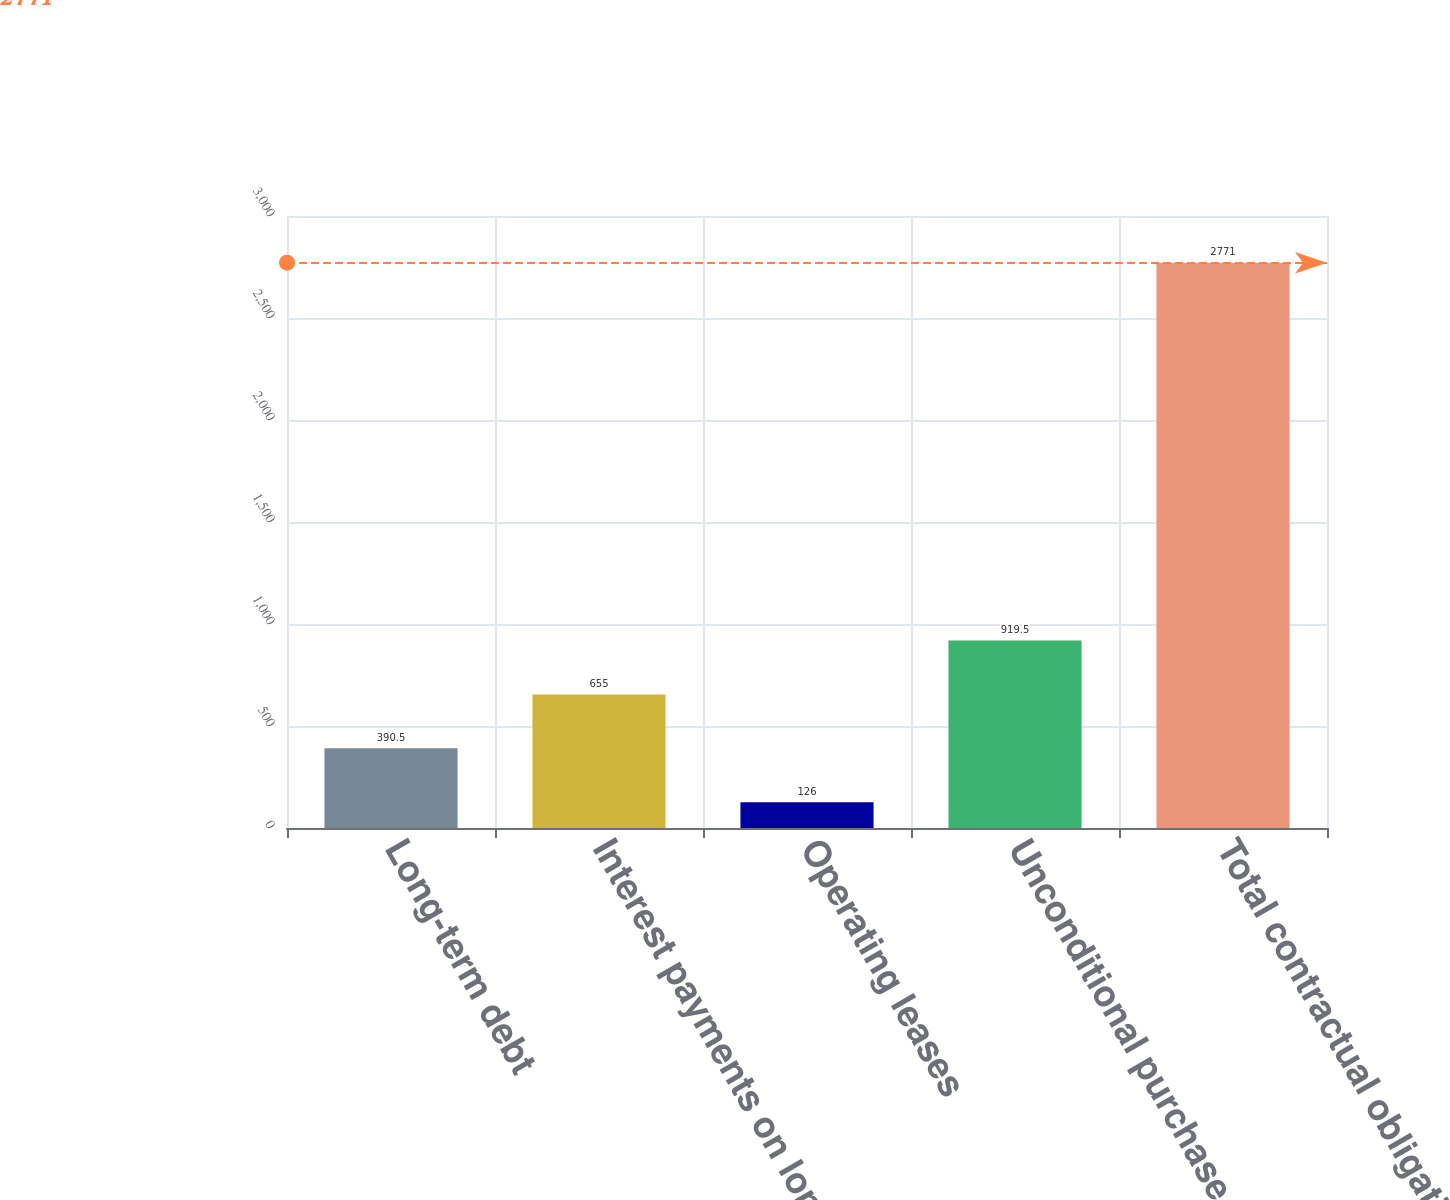Convert chart. <chart><loc_0><loc_0><loc_500><loc_500><bar_chart><fcel>Long-term debt<fcel>Interest payments on long-term<fcel>Operating leases<fcel>Unconditional purchase<fcel>Total contractual obligations<nl><fcel>390.5<fcel>655<fcel>126<fcel>919.5<fcel>2771<nl></chart> 